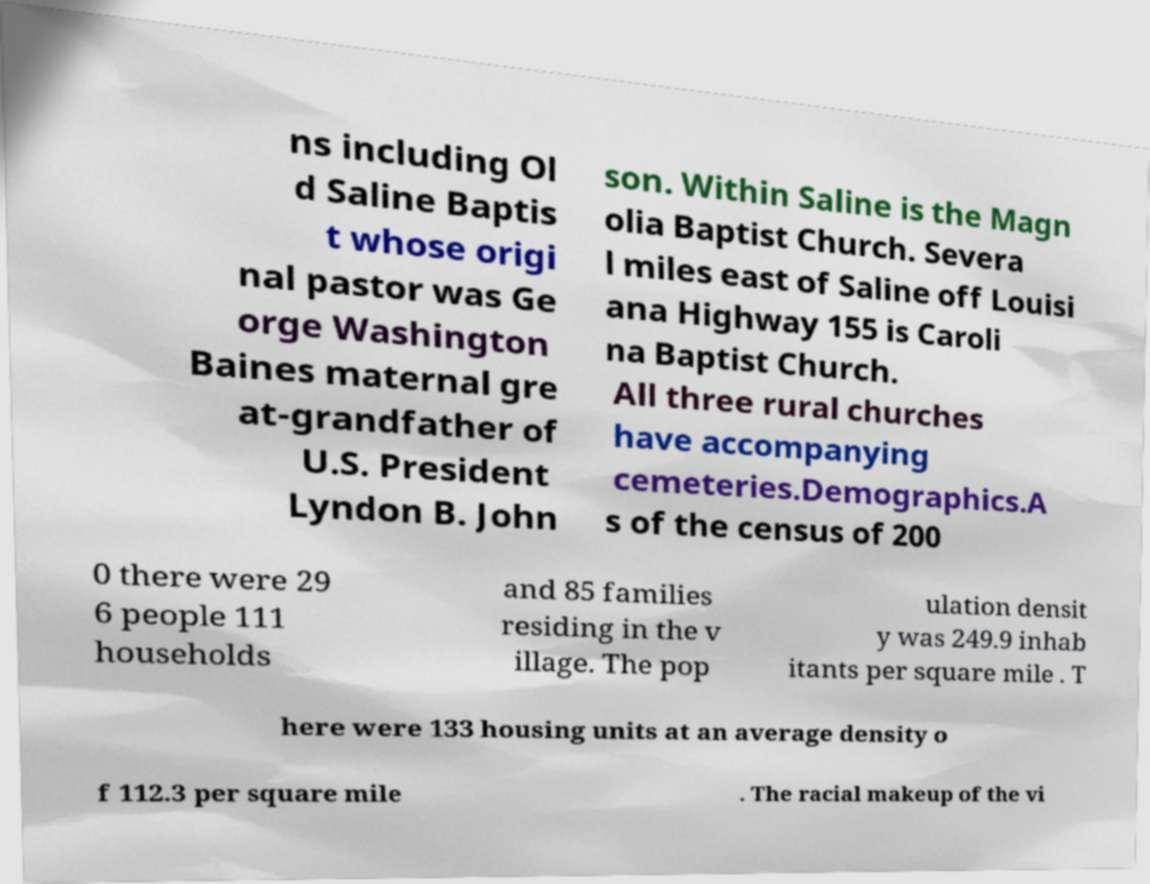Please read and relay the text visible in this image. What does it say? ns including Ol d Saline Baptis t whose origi nal pastor was Ge orge Washington Baines maternal gre at-grandfather of U.S. President Lyndon B. John son. Within Saline is the Magn olia Baptist Church. Severa l miles east of Saline off Louisi ana Highway 155 is Caroli na Baptist Church. All three rural churches have accompanying cemeteries.Demographics.A s of the census of 200 0 there were 29 6 people 111 households and 85 families residing in the v illage. The pop ulation densit y was 249.9 inhab itants per square mile . T here were 133 housing units at an average density o f 112.3 per square mile . The racial makeup of the vi 